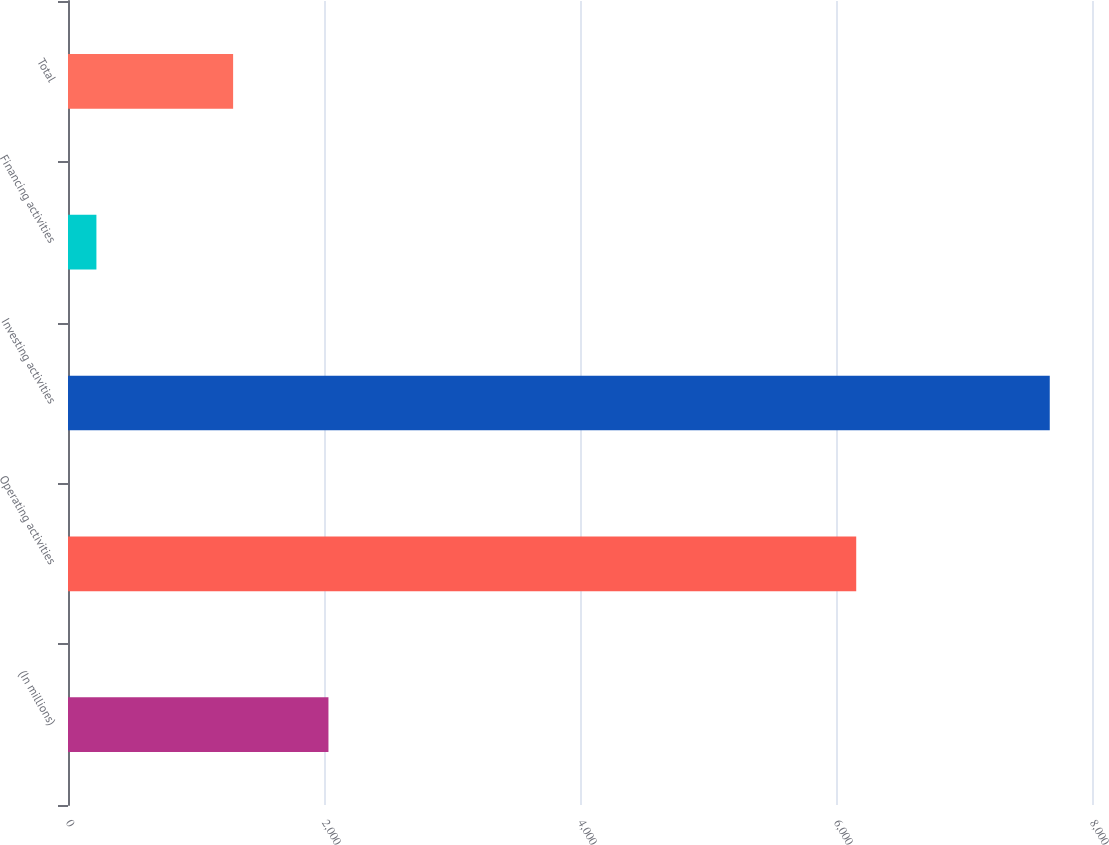Convert chart to OTSL. <chart><loc_0><loc_0><loc_500><loc_500><bar_chart><fcel>(In millions)<fcel>Operating activities<fcel>Investing activities<fcel>Financing activities<fcel>Total<nl><fcel>2034.8<fcel>6158<fcel>7670<fcel>222<fcel>1290<nl></chart> 